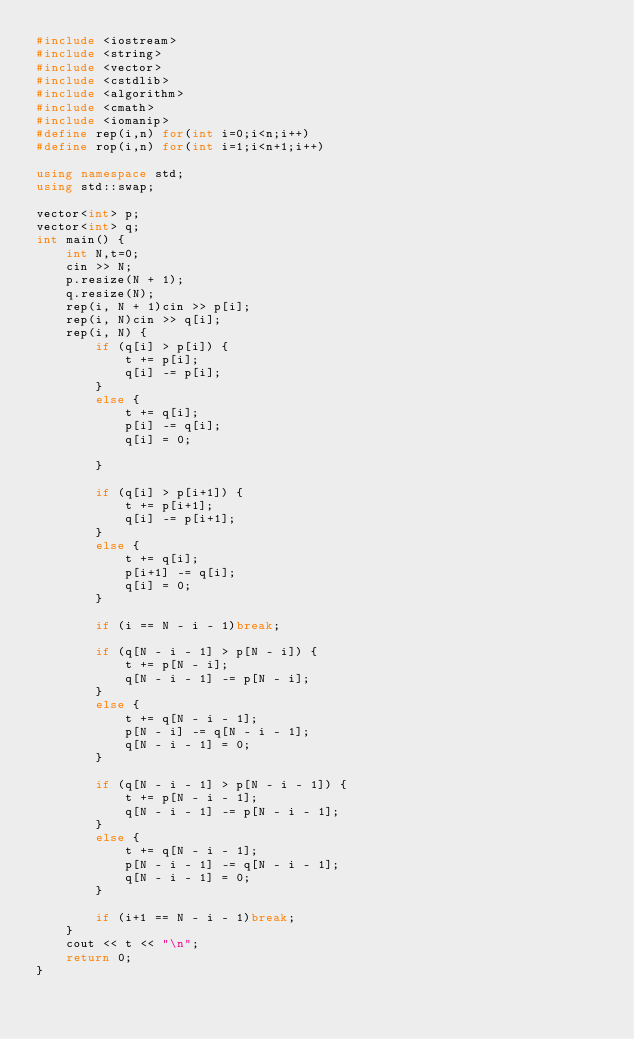Convert code to text. <code><loc_0><loc_0><loc_500><loc_500><_C++_>#include <iostream>
#include <string>
#include <vector>
#include <cstdlib>
#include <algorithm>
#include <cmath>
#include <iomanip>
#define rep(i,n) for(int i=0;i<n;i++)
#define rop(i,n) for(int i=1;i<n+1;i++)

using namespace std;
using std::swap;

vector<int> p;
vector<int> q;
int main() {
	int N,t=0;
	cin >> N;
	p.resize(N + 1);
	q.resize(N);
	rep(i, N + 1)cin >> p[i];
	rep(i, N)cin >> q[i];
	rep(i, N) {
		if (q[i] > p[i]) {
			t += p[i];
			q[i] -= p[i];
		}
		else {
			t += q[i];
			p[i] -= q[i];
			q[i] = 0;
			
		}

		if (q[i] > p[i+1]) {
			t += p[i+1];
			q[i] -= p[i+1];
		}
		else {
			t += q[i];
			p[i+1] -= q[i];
			q[i] = 0;
		}

		if (i == N - i - 1)break;

		if (q[N - i - 1] > p[N - i]) {
			t += p[N - i];
			q[N - i - 1] -= p[N - i];
		}
		else {
			t += q[N - i - 1];
			p[N - i] -= q[N - i - 1];
			q[N - i - 1] = 0;
		}

		if (q[N - i - 1] > p[N - i - 1]) {
			t += p[N - i - 1];
			q[N - i - 1] -= p[N - i - 1];
		}
		else {
			t += q[N - i - 1];
			p[N - i - 1] -= q[N - i - 1];
			q[N - i - 1] = 0;
		}

		if (i+1 == N - i - 1)break;
	}
	cout << t << "\n";
	return 0;
}</code> 